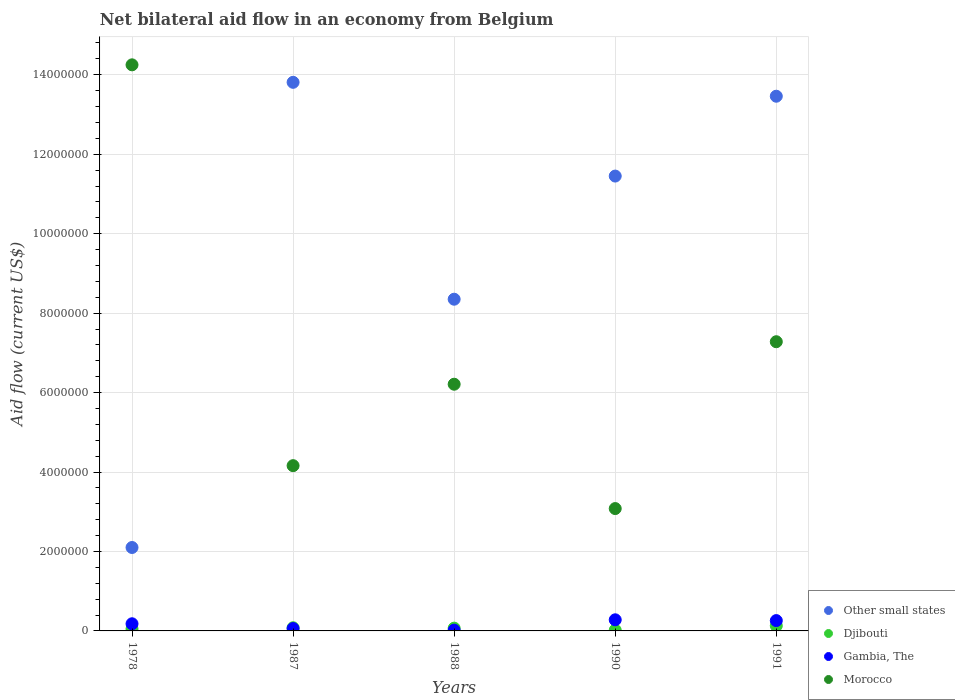Is the number of dotlines equal to the number of legend labels?
Provide a succinct answer. Yes. What is the net bilateral aid flow in Other small states in 1987?
Make the answer very short. 1.38e+07. Across all years, what is the maximum net bilateral aid flow in Gambia, The?
Offer a very short reply. 2.80e+05. Across all years, what is the minimum net bilateral aid flow in Other small states?
Offer a very short reply. 2.10e+06. What is the total net bilateral aid flow in Morocco in the graph?
Provide a succinct answer. 3.50e+07. What is the difference between the net bilateral aid flow in Djibouti in 1978 and the net bilateral aid flow in Morocco in 1990?
Your response must be concise. -3.03e+06. What is the average net bilateral aid flow in Gambia, The per year?
Give a very brief answer. 1.60e+05. In the year 1990, what is the difference between the net bilateral aid flow in Gambia, The and net bilateral aid flow in Djibouti?
Provide a short and direct response. 2.60e+05. What is the ratio of the net bilateral aid flow in Djibouti in 1990 to that in 1991?
Your answer should be very brief. 0.15. Is the net bilateral aid flow in Djibouti in 1978 less than that in 1987?
Ensure brevity in your answer.  Yes. Is the difference between the net bilateral aid flow in Gambia, The in 1988 and 1991 greater than the difference between the net bilateral aid flow in Djibouti in 1988 and 1991?
Your response must be concise. No. What is the difference between the highest and the lowest net bilateral aid flow in Other small states?
Offer a very short reply. 1.17e+07. Is it the case that in every year, the sum of the net bilateral aid flow in Other small states and net bilateral aid flow in Gambia, The  is greater than the sum of net bilateral aid flow in Morocco and net bilateral aid flow in Djibouti?
Your response must be concise. Yes. Does the net bilateral aid flow in Other small states monotonically increase over the years?
Keep it short and to the point. No. How many dotlines are there?
Keep it short and to the point. 4. How many years are there in the graph?
Your answer should be very brief. 5. What is the difference between two consecutive major ticks on the Y-axis?
Offer a very short reply. 2.00e+06. Where does the legend appear in the graph?
Your answer should be compact. Bottom right. How many legend labels are there?
Keep it short and to the point. 4. What is the title of the graph?
Your answer should be compact. Net bilateral aid flow in an economy from Belgium. What is the label or title of the X-axis?
Your answer should be very brief. Years. What is the label or title of the Y-axis?
Provide a short and direct response. Aid flow (current US$). What is the Aid flow (current US$) in Other small states in 1978?
Keep it short and to the point. 2.10e+06. What is the Aid flow (current US$) of Gambia, The in 1978?
Keep it short and to the point. 1.80e+05. What is the Aid flow (current US$) of Morocco in 1978?
Offer a very short reply. 1.42e+07. What is the Aid flow (current US$) in Other small states in 1987?
Offer a terse response. 1.38e+07. What is the Aid flow (current US$) in Gambia, The in 1987?
Keep it short and to the point. 6.00e+04. What is the Aid flow (current US$) in Morocco in 1987?
Provide a succinct answer. 4.16e+06. What is the Aid flow (current US$) in Other small states in 1988?
Offer a terse response. 8.35e+06. What is the Aid flow (current US$) of Djibouti in 1988?
Keep it short and to the point. 7.00e+04. What is the Aid flow (current US$) in Morocco in 1988?
Your answer should be compact. 6.21e+06. What is the Aid flow (current US$) of Other small states in 1990?
Ensure brevity in your answer.  1.14e+07. What is the Aid flow (current US$) of Morocco in 1990?
Give a very brief answer. 3.08e+06. What is the Aid flow (current US$) of Other small states in 1991?
Your response must be concise. 1.35e+07. What is the Aid flow (current US$) of Djibouti in 1991?
Give a very brief answer. 1.30e+05. What is the Aid flow (current US$) in Gambia, The in 1991?
Give a very brief answer. 2.60e+05. What is the Aid flow (current US$) of Morocco in 1991?
Your response must be concise. 7.28e+06. Across all years, what is the maximum Aid flow (current US$) of Other small states?
Provide a short and direct response. 1.38e+07. Across all years, what is the maximum Aid flow (current US$) of Djibouti?
Your answer should be compact. 1.30e+05. Across all years, what is the maximum Aid flow (current US$) in Morocco?
Your answer should be very brief. 1.42e+07. Across all years, what is the minimum Aid flow (current US$) in Other small states?
Your response must be concise. 2.10e+06. Across all years, what is the minimum Aid flow (current US$) of Djibouti?
Provide a short and direct response. 2.00e+04. Across all years, what is the minimum Aid flow (current US$) in Morocco?
Offer a very short reply. 3.08e+06. What is the total Aid flow (current US$) of Other small states in the graph?
Your response must be concise. 4.92e+07. What is the total Aid flow (current US$) in Djibouti in the graph?
Ensure brevity in your answer.  3.50e+05. What is the total Aid flow (current US$) in Morocco in the graph?
Your answer should be compact. 3.50e+07. What is the difference between the Aid flow (current US$) of Other small states in 1978 and that in 1987?
Ensure brevity in your answer.  -1.17e+07. What is the difference between the Aid flow (current US$) of Djibouti in 1978 and that in 1987?
Your answer should be very brief. -3.00e+04. What is the difference between the Aid flow (current US$) in Gambia, The in 1978 and that in 1987?
Offer a terse response. 1.20e+05. What is the difference between the Aid flow (current US$) in Morocco in 1978 and that in 1987?
Provide a succinct answer. 1.01e+07. What is the difference between the Aid flow (current US$) of Other small states in 1978 and that in 1988?
Provide a succinct answer. -6.25e+06. What is the difference between the Aid flow (current US$) in Morocco in 1978 and that in 1988?
Make the answer very short. 8.04e+06. What is the difference between the Aid flow (current US$) of Other small states in 1978 and that in 1990?
Provide a short and direct response. -9.35e+06. What is the difference between the Aid flow (current US$) of Gambia, The in 1978 and that in 1990?
Provide a succinct answer. -1.00e+05. What is the difference between the Aid flow (current US$) of Morocco in 1978 and that in 1990?
Make the answer very short. 1.12e+07. What is the difference between the Aid flow (current US$) in Other small states in 1978 and that in 1991?
Give a very brief answer. -1.14e+07. What is the difference between the Aid flow (current US$) in Morocco in 1978 and that in 1991?
Your response must be concise. 6.97e+06. What is the difference between the Aid flow (current US$) in Other small states in 1987 and that in 1988?
Provide a short and direct response. 5.46e+06. What is the difference between the Aid flow (current US$) in Djibouti in 1987 and that in 1988?
Offer a terse response. 10000. What is the difference between the Aid flow (current US$) of Gambia, The in 1987 and that in 1988?
Your response must be concise. 4.00e+04. What is the difference between the Aid flow (current US$) of Morocco in 1987 and that in 1988?
Keep it short and to the point. -2.05e+06. What is the difference between the Aid flow (current US$) in Other small states in 1987 and that in 1990?
Provide a succinct answer. 2.36e+06. What is the difference between the Aid flow (current US$) of Djibouti in 1987 and that in 1990?
Offer a very short reply. 6.00e+04. What is the difference between the Aid flow (current US$) of Gambia, The in 1987 and that in 1990?
Your response must be concise. -2.20e+05. What is the difference between the Aid flow (current US$) in Morocco in 1987 and that in 1990?
Your answer should be very brief. 1.08e+06. What is the difference between the Aid flow (current US$) in Djibouti in 1987 and that in 1991?
Make the answer very short. -5.00e+04. What is the difference between the Aid flow (current US$) in Gambia, The in 1987 and that in 1991?
Your answer should be very brief. -2.00e+05. What is the difference between the Aid flow (current US$) of Morocco in 1987 and that in 1991?
Offer a very short reply. -3.12e+06. What is the difference between the Aid flow (current US$) in Other small states in 1988 and that in 1990?
Offer a very short reply. -3.10e+06. What is the difference between the Aid flow (current US$) in Morocco in 1988 and that in 1990?
Your answer should be very brief. 3.13e+06. What is the difference between the Aid flow (current US$) of Other small states in 1988 and that in 1991?
Your response must be concise. -5.11e+06. What is the difference between the Aid flow (current US$) in Morocco in 1988 and that in 1991?
Give a very brief answer. -1.07e+06. What is the difference between the Aid flow (current US$) of Other small states in 1990 and that in 1991?
Your response must be concise. -2.01e+06. What is the difference between the Aid flow (current US$) in Djibouti in 1990 and that in 1991?
Your answer should be compact. -1.10e+05. What is the difference between the Aid flow (current US$) in Gambia, The in 1990 and that in 1991?
Provide a short and direct response. 2.00e+04. What is the difference between the Aid flow (current US$) in Morocco in 1990 and that in 1991?
Your response must be concise. -4.20e+06. What is the difference between the Aid flow (current US$) of Other small states in 1978 and the Aid flow (current US$) of Djibouti in 1987?
Give a very brief answer. 2.02e+06. What is the difference between the Aid flow (current US$) of Other small states in 1978 and the Aid flow (current US$) of Gambia, The in 1987?
Provide a short and direct response. 2.04e+06. What is the difference between the Aid flow (current US$) in Other small states in 1978 and the Aid flow (current US$) in Morocco in 1987?
Your response must be concise. -2.06e+06. What is the difference between the Aid flow (current US$) in Djibouti in 1978 and the Aid flow (current US$) in Morocco in 1987?
Give a very brief answer. -4.11e+06. What is the difference between the Aid flow (current US$) in Gambia, The in 1978 and the Aid flow (current US$) in Morocco in 1987?
Make the answer very short. -3.98e+06. What is the difference between the Aid flow (current US$) in Other small states in 1978 and the Aid flow (current US$) in Djibouti in 1988?
Ensure brevity in your answer.  2.03e+06. What is the difference between the Aid flow (current US$) in Other small states in 1978 and the Aid flow (current US$) in Gambia, The in 1988?
Offer a very short reply. 2.08e+06. What is the difference between the Aid flow (current US$) in Other small states in 1978 and the Aid flow (current US$) in Morocco in 1988?
Keep it short and to the point. -4.11e+06. What is the difference between the Aid flow (current US$) of Djibouti in 1978 and the Aid flow (current US$) of Morocco in 1988?
Your answer should be compact. -6.16e+06. What is the difference between the Aid flow (current US$) in Gambia, The in 1978 and the Aid flow (current US$) in Morocco in 1988?
Your answer should be compact. -6.03e+06. What is the difference between the Aid flow (current US$) in Other small states in 1978 and the Aid flow (current US$) in Djibouti in 1990?
Give a very brief answer. 2.08e+06. What is the difference between the Aid flow (current US$) of Other small states in 1978 and the Aid flow (current US$) of Gambia, The in 1990?
Provide a succinct answer. 1.82e+06. What is the difference between the Aid flow (current US$) of Other small states in 1978 and the Aid flow (current US$) of Morocco in 1990?
Offer a terse response. -9.80e+05. What is the difference between the Aid flow (current US$) of Djibouti in 1978 and the Aid flow (current US$) of Morocco in 1990?
Ensure brevity in your answer.  -3.03e+06. What is the difference between the Aid flow (current US$) in Gambia, The in 1978 and the Aid flow (current US$) in Morocco in 1990?
Offer a very short reply. -2.90e+06. What is the difference between the Aid flow (current US$) of Other small states in 1978 and the Aid flow (current US$) of Djibouti in 1991?
Your answer should be very brief. 1.97e+06. What is the difference between the Aid flow (current US$) in Other small states in 1978 and the Aid flow (current US$) in Gambia, The in 1991?
Your answer should be compact. 1.84e+06. What is the difference between the Aid flow (current US$) of Other small states in 1978 and the Aid flow (current US$) of Morocco in 1991?
Your answer should be very brief. -5.18e+06. What is the difference between the Aid flow (current US$) in Djibouti in 1978 and the Aid flow (current US$) in Morocco in 1991?
Give a very brief answer. -7.23e+06. What is the difference between the Aid flow (current US$) of Gambia, The in 1978 and the Aid flow (current US$) of Morocco in 1991?
Your response must be concise. -7.10e+06. What is the difference between the Aid flow (current US$) in Other small states in 1987 and the Aid flow (current US$) in Djibouti in 1988?
Keep it short and to the point. 1.37e+07. What is the difference between the Aid flow (current US$) of Other small states in 1987 and the Aid flow (current US$) of Gambia, The in 1988?
Keep it short and to the point. 1.38e+07. What is the difference between the Aid flow (current US$) in Other small states in 1987 and the Aid flow (current US$) in Morocco in 1988?
Provide a succinct answer. 7.60e+06. What is the difference between the Aid flow (current US$) in Djibouti in 1987 and the Aid flow (current US$) in Morocco in 1988?
Your answer should be very brief. -6.13e+06. What is the difference between the Aid flow (current US$) in Gambia, The in 1987 and the Aid flow (current US$) in Morocco in 1988?
Make the answer very short. -6.15e+06. What is the difference between the Aid flow (current US$) of Other small states in 1987 and the Aid flow (current US$) of Djibouti in 1990?
Offer a very short reply. 1.38e+07. What is the difference between the Aid flow (current US$) in Other small states in 1987 and the Aid flow (current US$) in Gambia, The in 1990?
Ensure brevity in your answer.  1.35e+07. What is the difference between the Aid flow (current US$) in Other small states in 1987 and the Aid flow (current US$) in Morocco in 1990?
Offer a terse response. 1.07e+07. What is the difference between the Aid flow (current US$) of Djibouti in 1987 and the Aid flow (current US$) of Gambia, The in 1990?
Provide a short and direct response. -2.00e+05. What is the difference between the Aid flow (current US$) of Djibouti in 1987 and the Aid flow (current US$) of Morocco in 1990?
Your answer should be very brief. -3.00e+06. What is the difference between the Aid flow (current US$) of Gambia, The in 1987 and the Aid flow (current US$) of Morocco in 1990?
Make the answer very short. -3.02e+06. What is the difference between the Aid flow (current US$) in Other small states in 1987 and the Aid flow (current US$) in Djibouti in 1991?
Provide a short and direct response. 1.37e+07. What is the difference between the Aid flow (current US$) in Other small states in 1987 and the Aid flow (current US$) in Gambia, The in 1991?
Keep it short and to the point. 1.36e+07. What is the difference between the Aid flow (current US$) in Other small states in 1987 and the Aid flow (current US$) in Morocco in 1991?
Provide a succinct answer. 6.53e+06. What is the difference between the Aid flow (current US$) in Djibouti in 1987 and the Aid flow (current US$) in Gambia, The in 1991?
Offer a terse response. -1.80e+05. What is the difference between the Aid flow (current US$) in Djibouti in 1987 and the Aid flow (current US$) in Morocco in 1991?
Keep it short and to the point. -7.20e+06. What is the difference between the Aid flow (current US$) in Gambia, The in 1987 and the Aid flow (current US$) in Morocco in 1991?
Your answer should be compact. -7.22e+06. What is the difference between the Aid flow (current US$) in Other small states in 1988 and the Aid flow (current US$) in Djibouti in 1990?
Offer a very short reply. 8.33e+06. What is the difference between the Aid flow (current US$) in Other small states in 1988 and the Aid flow (current US$) in Gambia, The in 1990?
Offer a very short reply. 8.07e+06. What is the difference between the Aid flow (current US$) of Other small states in 1988 and the Aid flow (current US$) of Morocco in 1990?
Your answer should be compact. 5.27e+06. What is the difference between the Aid flow (current US$) of Djibouti in 1988 and the Aid flow (current US$) of Gambia, The in 1990?
Provide a succinct answer. -2.10e+05. What is the difference between the Aid flow (current US$) in Djibouti in 1988 and the Aid flow (current US$) in Morocco in 1990?
Ensure brevity in your answer.  -3.01e+06. What is the difference between the Aid flow (current US$) of Gambia, The in 1988 and the Aid flow (current US$) of Morocco in 1990?
Make the answer very short. -3.06e+06. What is the difference between the Aid flow (current US$) of Other small states in 1988 and the Aid flow (current US$) of Djibouti in 1991?
Offer a very short reply. 8.22e+06. What is the difference between the Aid flow (current US$) in Other small states in 1988 and the Aid flow (current US$) in Gambia, The in 1991?
Provide a short and direct response. 8.09e+06. What is the difference between the Aid flow (current US$) of Other small states in 1988 and the Aid flow (current US$) of Morocco in 1991?
Offer a very short reply. 1.07e+06. What is the difference between the Aid flow (current US$) in Djibouti in 1988 and the Aid flow (current US$) in Morocco in 1991?
Provide a short and direct response. -7.21e+06. What is the difference between the Aid flow (current US$) of Gambia, The in 1988 and the Aid flow (current US$) of Morocco in 1991?
Keep it short and to the point. -7.26e+06. What is the difference between the Aid flow (current US$) in Other small states in 1990 and the Aid flow (current US$) in Djibouti in 1991?
Ensure brevity in your answer.  1.13e+07. What is the difference between the Aid flow (current US$) of Other small states in 1990 and the Aid flow (current US$) of Gambia, The in 1991?
Your response must be concise. 1.12e+07. What is the difference between the Aid flow (current US$) in Other small states in 1990 and the Aid flow (current US$) in Morocco in 1991?
Give a very brief answer. 4.17e+06. What is the difference between the Aid flow (current US$) of Djibouti in 1990 and the Aid flow (current US$) of Gambia, The in 1991?
Provide a short and direct response. -2.40e+05. What is the difference between the Aid flow (current US$) of Djibouti in 1990 and the Aid flow (current US$) of Morocco in 1991?
Keep it short and to the point. -7.26e+06. What is the difference between the Aid flow (current US$) in Gambia, The in 1990 and the Aid flow (current US$) in Morocco in 1991?
Keep it short and to the point. -7.00e+06. What is the average Aid flow (current US$) of Other small states per year?
Provide a short and direct response. 9.83e+06. What is the average Aid flow (current US$) of Djibouti per year?
Your response must be concise. 7.00e+04. What is the average Aid flow (current US$) of Morocco per year?
Keep it short and to the point. 7.00e+06. In the year 1978, what is the difference between the Aid flow (current US$) in Other small states and Aid flow (current US$) in Djibouti?
Your answer should be very brief. 2.05e+06. In the year 1978, what is the difference between the Aid flow (current US$) in Other small states and Aid flow (current US$) in Gambia, The?
Keep it short and to the point. 1.92e+06. In the year 1978, what is the difference between the Aid flow (current US$) in Other small states and Aid flow (current US$) in Morocco?
Provide a short and direct response. -1.22e+07. In the year 1978, what is the difference between the Aid flow (current US$) of Djibouti and Aid flow (current US$) of Morocco?
Ensure brevity in your answer.  -1.42e+07. In the year 1978, what is the difference between the Aid flow (current US$) in Gambia, The and Aid flow (current US$) in Morocco?
Make the answer very short. -1.41e+07. In the year 1987, what is the difference between the Aid flow (current US$) in Other small states and Aid flow (current US$) in Djibouti?
Your answer should be very brief. 1.37e+07. In the year 1987, what is the difference between the Aid flow (current US$) in Other small states and Aid flow (current US$) in Gambia, The?
Your answer should be very brief. 1.38e+07. In the year 1987, what is the difference between the Aid flow (current US$) of Other small states and Aid flow (current US$) of Morocco?
Keep it short and to the point. 9.65e+06. In the year 1987, what is the difference between the Aid flow (current US$) of Djibouti and Aid flow (current US$) of Gambia, The?
Offer a terse response. 2.00e+04. In the year 1987, what is the difference between the Aid flow (current US$) of Djibouti and Aid flow (current US$) of Morocco?
Offer a terse response. -4.08e+06. In the year 1987, what is the difference between the Aid flow (current US$) of Gambia, The and Aid flow (current US$) of Morocco?
Provide a succinct answer. -4.10e+06. In the year 1988, what is the difference between the Aid flow (current US$) of Other small states and Aid flow (current US$) of Djibouti?
Provide a succinct answer. 8.28e+06. In the year 1988, what is the difference between the Aid flow (current US$) of Other small states and Aid flow (current US$) of Gambia, The?
Ensure brevity in your answer.  8.33e+06. In the year 1988, what is the difference between the Aid flow (current US$) in Other small states and Aid flow (current US$) in Morocco?
Provide a short and direct response. 2.14e+06. In the year 1988, what is the difference between the Aid flow (current US$) in Djibouti and Aid flow (current US$) in Gambia, The?
Your answer should be compact. 5.00e+04. In the year 1988, what is the difference between the Aid flow (current US$) of Djibouti and Aid flow (current US$) of Morocco?
Your response must be concise. -6.14e+06. In the year 1988, what is the difference between the Aid flow (current US$) of Gambia, The and Aid flow (current US$) of Morocco?
Provide a succinct answer. -6.19e+06. In the year 1990, what is the difference between the Aid flow (current US$) of Other small states and Aid flow (current US$) of Djibouti?
Provide a short and direct response. 1.14e+07. In the year 1990, what is the difference between the Aid flow (current US$) in Other small states and Aid flow (current US$) in Gambia, The?
Your answer should be very brief. 1.12e+07. In the year 1990, what is the difference between the Aid flow (current US$) of Other small states and Aid flow (current US$) of Morocco?
Offer a very short reply. 8.37e+06. In the year 1990, what is the difference between the Aid flow (current US$) of Djibouti and Aid flow (current US$) of Gambia, The?
Your response must be concise. -2.60e+05. In the year 1990, what is the difference between the Aid flow (current US$) of Djibouti and Aid flow (current US$) of Morocco?
Keep it short and to the point. -3.06e+06. In the year 1990, what is the difference between the Aid flow (current US$) in Gambia, The and Aid flow (current US$) in Morocco?
Your answer should be compact. -2.80e+06. In the year 1991, what is the difference between the Aid flow (current US$) of Other small states and Aid flow (current US$) of Djibouti?
Provide a succinct answer. 1.33e+07. In the year 1991, what is the difference between the Aid flow (current US$) of Other small states and Aid flow (current US$) of Gambia, The?
Your answer should be very brief. 1.32e+07. In the year 1991, what is the difference between the Aid flow (current US$) of Other small states and Aid flow (current US$) of Morocco?
Ensure brevity in your answer.  6.18e+06. In the year 1991, what is the difference between the Aid flow (current US$) in Djibouti and Aid flow (current US$) in Morocco?
Your response must be concise. -7.15e+06. In the year 1991, what is the difference between the Aid flow (current US$) of Gambia, The and Aid flow (current US$) of Morocco?
Keep it short and to the point. -7.02e+06. What is the ratio of the Aid flow (current US$) of Other small states in 1978 to that in 1987?
Ensure brevity in your answer.  0.15. What is the ratio of the Aid flow (current US$) of Djibouti in 1978 to that in 1987?
Make the answer very short. 0.62. What is the ratio of the Aid flow (current US$) in Gambia, The in 1978 to that in 1987?
Your response must be concise. 3. What is the ratio of the Aid flow (current US$) in Morocco in 1978 to that in 1987?
Make the answer very short. 3.43. What is the ratio of the Aid flow (current US$) of Other small states in 1978 to that in 1988?
Make the answer very short. 0.25. What is the ratio of the Aid flow (current US$) in Djibouti in 1978 to that in 1988?
Your answer should be compact. 0.71. What is the ratio of the Aid flow (current US$) in Gambia, The in 1978 to that in 1988?
Offer a terse response. 9. What is the ratio of the Aid flow (current US$) of Morocco in 1978 to that in 1988?
Make the answer very short. 2.29. What is the ratio of the Aid flow (current US$) of Other small states in 1978 to that in 1990?
Provide a succinct answer. 0.18. What is the ratio of the Aid flow (current US$) in Gambia, The in 1978 to that in 1990?
Your answer should be very brief. 0.64. What is the ratio of the Aid flow (current US$) in Morocco in 1978 to that in 1990?
Provide a short and direct response. 4.63. What is the ratio of the Aid flow (current US$) in Other small states in 1978 to that in 1991?
Your response must be concise. 0.16. What is the ratio of the Aid flow (current US$) of Djibouti in 1978 to that in 1991?
Provide a succinct answer. 0.38. What is the ratio of the Aid flow (current US$) in Gambia, The in 1978 to that in 1991?
Your response must be concise. 0.69. What is the ratio of the Aid flow (current US$) in Morocco in 1978 to that in 1991?
Make the answer very short. 1.96. What is the ratio of the Aid flow (current US$) of Other small states in 1987 to that in 1988?
Give a very brief answer. 1.65. What is the ratio of the Aid flow (current US$) of Djibouti in 1987 to that in 1988?
Offer a very short reply. 1.14. What is the ratio of the Aid flow (current US$) of Gambia, The in 1987 to that in 1988?
Give a very brief answer. 3. What is the ratio of the Aid flow (current US$) in Morocco in 1987 to that in 1988?
Provide a short and direct response. 0.67. What is the ratio of the Aid flow (current US$) in Other small states in 1987 to that in 1990?
Give a very brief answer. 1.21. What is the ratio of the Aid flow (current US$) of Djibouti in 1987 to that in 1990?
Ensure brevity in your answer.  4. What is the ratio of the Aid flow (current US$) in Gambia, The in 1987 to that in 1990?
Ensure brevity in your answer.  0.21. What is the ratio of the Aid flow (current US$) of Morocco in 1987 to that in 1990?
Provide a succinct answer. 1.35. What is the ratio of the Aid flow (current US$) in Other small states in 1987 to that in 1991?
Provide a short and direct response. 1.03. What is the ratio of the Aid flow (current US$) in Djibouti in 1987 to that in 1991?
Your answer should be very brief. 0.62. What is the ratio of the Aid flow (current US$) in Gambia, The in 1987 to that in 1991?
Your answer should be very brief. 0.23. What is the ratio of the Aid flow (current US$) of Morocco in 1987 to that in 1991?
Your answer should be very brief. 0.57. What is the ratio of the Aid flow (current US$) in Other small states in 1988 to that in 1990?
Make the answer very short. 0.73. What is the ratio of the Aid flow (current US$) in Gambia, The in 1988 to that in 1990?
Give a very brief answer. 0.07. What is the ratio of the Aid flow (current US$) of Morocco in 1988 to that in 1990?
Make the answer very short. 2.02. What is the ratio of the Aid flow (current US$) in Other small states in 1988 to that in 1991?
Give a very brief answer. 0.62. What is the ratio of the Aid flow (current US$) in Djibouti in 1988 to that in 1991?
Your answer should be compact. 0.54. What is the ratio of the Aid flow (current US$) of Gambia, The in 1988 to that in 1991?
Ensure brevity in your answer.  0.08. What is the ratio of the Aid flow (current US$) of Morocco in 1988 to that in 1991?
Your answer should be compact. 0.85. What is the ratio of the Aid flow (current US$) in Other small states in 1990 to that in 1991?
Your answer should be compact. 0.85. What is the ratio of the Aid flow (current US$) in Djibouti in 1990 to that in 1991?
Your answer should be compact. 0.15. What is the ratio of the Aid flow (current US$) in Morocco in 1990 to that in 1991?
Provide a succinct answer. 0.42. What is the difference between the highest and the second highest Aid flow (current US$) of Gambia, The?
Your answer should be very brief. 2.00e+04. What is the difference between the highest and the second highest Aid flow (current US$) in Morocco?
Your answer should be compact. 6.97e+06. What is the difference between the highest and the lowest Aid flow (current US$) in Other small states?
Keep it short and to the point. 1.17e+07. What is the difference between the highest and the lowest Aid flow (current US$) in Gambia, The?
Keep it short and to the point. 2.60e+05. What is the difference between the highest and the lowest Aid flow (current US$) of Morocco?
Your answer should be compact. 1.12e+07. 